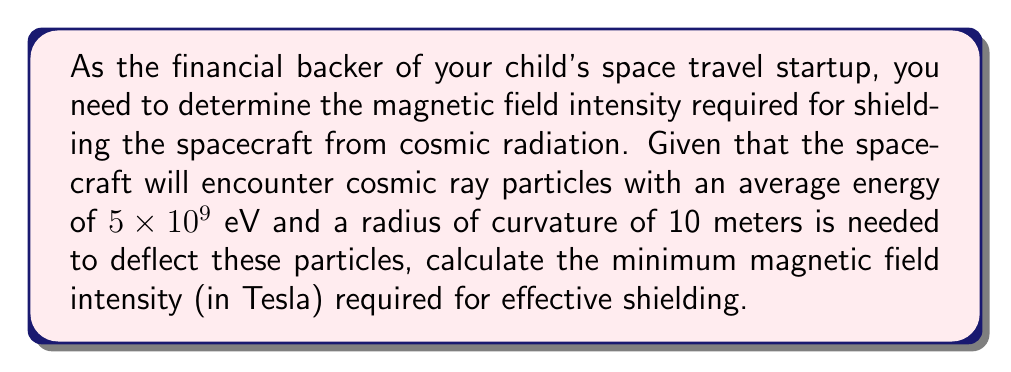Could you help me with this problem? To solve this problem, we'll use the concept of magnetic rigidity, which relates the magnetic field strength to the radius of curvature of a charged particle's path.

Step 1: Recall the formula for magnetic rigidity:
$$ B\rho = \frac{p}{q} $$
Where:
$B$ = magnetic field intensity (T)
$\rho$ = radius of curvature (m)
$p$ = momentum of the particle (kg⋅m/s)
$q$ = charge of the particle (C)

Step 2: We need to find the momentum of the cosmic ray particles. We can use the relativistic energy-momentum relation:
$$ E^2 = (pc)^2 + (mc^2)^2 $$
Where:
$E$ = total energy of the particle
$p$ = momentum
$c$ = speed of light
$m$ = rest mass of the particle

For highly relativistic particles (like cosmic rays), we can approximate $E \approx pc$, so:
$$ p \approx \frac{E}{c} $$

Step 3: Calculate the momentum:
$$ p \approx \frac{5 \times 10^9 \text{ eV}}{c} = \frac{5 \times 10^9 \times 1.602 \times 10^{-19} \text{ J}}{2.998 \times 10^8 \text{ m/s}} = 2.67 \times 10^{-18} \text{ kg⋅m/s} $$

Step 4: Use the magnetic rigidity formula to find $B$:
$$ B = \frac{p}{q\rho} $$

The charge $q$ for a proton (common in cosmic rays) is $1.602 \times 10^{-19}$ C.

$$ B = \frac{2.67 \times 10^{-18} \text{ kg⋅m/s}}{(1.602 \times 10^{-19} \text{ C})(10 \text{ m})} = 0.167 \text{ T} $$

Therefore, the minimum magnetic field intensity required is approximately 0.167 Tesla.
Answer: 0.167 T 